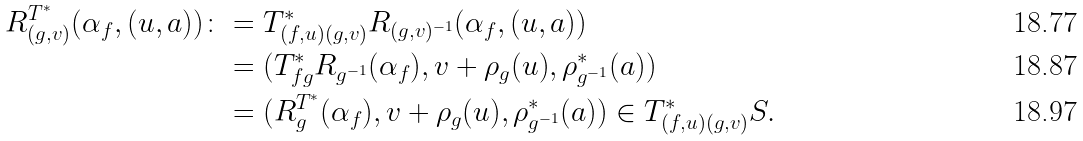<formula> <loc_0><loc_0><loc_500><loc_500>R ^ { T ^ { * } } _ { ( g , v ) } ( \alpha _ { f } , ( u , a ) ) \colon & = T _ { ( f , u ) ( g , v ) } ^ { * } R _ { ( g , v ) ^ { - 1 } } ( \alpha _ { f } , ( u , a ) ) \\ & = ( T _ { f g } ^ { * } R _ { g ^ { - 1 } } ( \alpha _ { f } ) , v + \rho _ { g } ( u ) , \rho _ { g ^ { - 1 } } ^ { * } ( a ) ) \\ & = ( R ^ { T ^ { * } } _ { g } ( \alpha _ { f } ) , v + \rho _ { g } ( u ) , \rho _ { g ^ { - 1 } } ^ { * } ( a ) ) \in T ^ { * } _ { ( f , u ) ( g , v ) } S .</formula> 